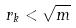<formula> <loc_0><loc_0><loc_500><loc_500>r _ { k } < \sqrt { m }</formula> 